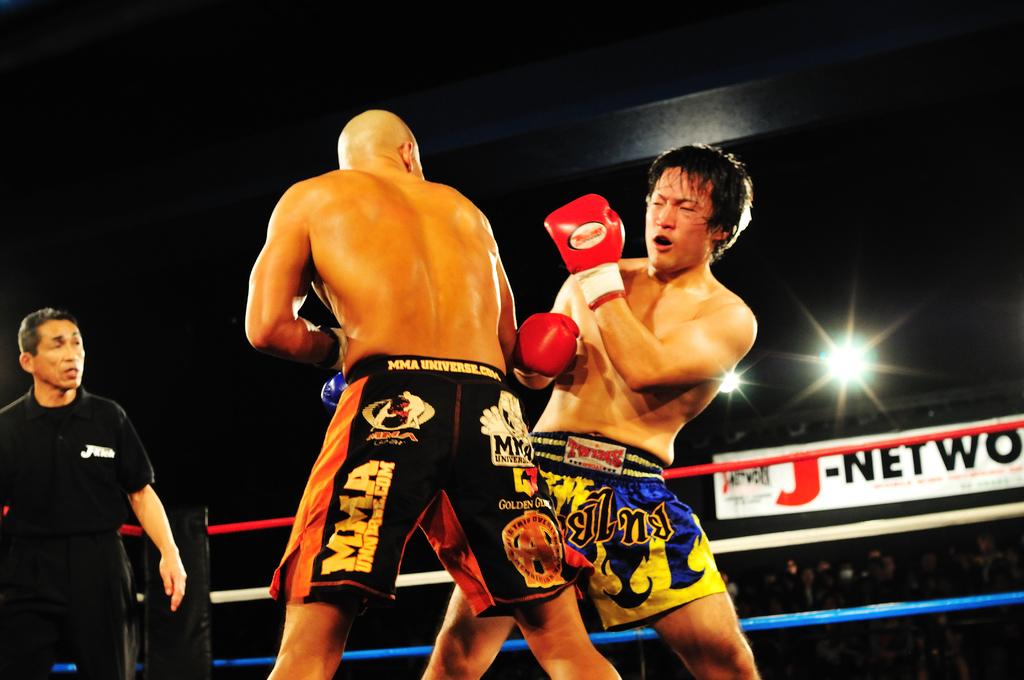What is on the players shorts?
Ensure brevity in your answer.  Mma. 